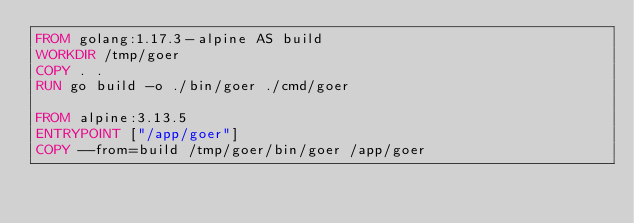<code> <loc_0><loc_0><loc_500><loc_500><_Dockerfile_>FROM golang:1.17.3-alpine AS build
WORKDIR /tmp/goer
COPY . .
RUN go build -o ./bin/goer ./cmd/goer

FROM alpine:3.13.5
ENTRYPOINT ["/app/goer"]
COPY --from=build /tmp/goer/bin/goer /app/goer
</code> 